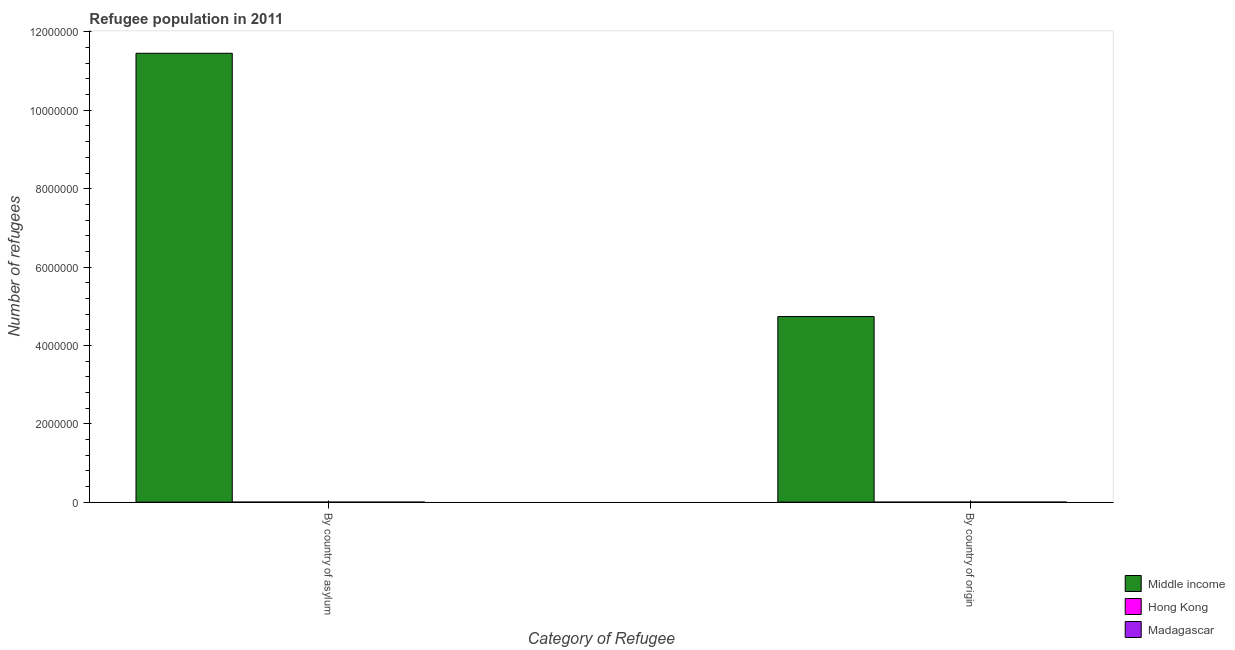Are the number of bars on each tick of the X-axis equal?
Your response must be concise. Yes. How many bars are there on the 2nd tick from the left?
Ensure brevity in your answer.  3. What is the label of the 2nd group of bars from the left?
Your response must be concise. By country of origin. What is the number of refugees by country of asylum in Madagascar?
Your answer should be very brief. 9. Across all countries, what is the maximum number of refugees by country of asylum?
Give a very brief answer. 1.15e+07. Across all countries, what is the minimum number of refugees by country of origin?
Give a very brief answer. 15. In which country was the number of refugees by country of origin minimum?
Keep it short and to the point. Hong Kong. What is the total number of refugees by country of asylum in the graph?
Provide a short and direct response. 1.15e+07. What is the difference between the number of refugees by country of asylum in Hong Kong and that in Madagascar?
Your answer should be compact. 143. What is the difference between the number of refugees by country of asylum in Madagascar and the number of refugees by country of origin in Hong Kong?
Provide a succinct answer. -6. What is the average number of refugees by country of asylum per country?
Ensure brevity in your answer.  3.82e+06. What is the difference between the number of refugees by country of origin and number of refugees by country of asylum in Hong Kong?
Provide a short and direct response. -137. In how many countries, is the number of refugees by country of asylum greater than 9600000 ?
Give a very brief answer. 1. What is the ratio of the number of refugees by country of origin in Middle income to that in Hong Kong?
Give a very brief answer. 3.16e+05. In how many countries, is the number of refugees by country of asylum greater than the average number of refugees by country of asylum taken over all countries?
Your answer should be compact. 1. What does the 2nd bar from the left in By country of origin represents?
Offer a terse response. Hong Kong. What does the 3rd bar from the right in By country of origin represents?
Ensure brevity in your answer.  Middle income. What is the difference between two consecutive major ticks on the Y-axis?
Offer a terse response. 2.00e+06. Are the values on the major ticks of Y-axis written in scientific E-notation?
Your response must be concise. No. How many legend labels are there?
Ensure brevity in your answer.  3. What is the title of the graph?
Your response must be concise. Refugee population in 2011. What is the label or title of the X-axis?
Give a very brief answer. Category of Refugee. What is the label or title of the Y-axis?
Your answer should be compact. Number of refugees. What is the Number of refugees in Middle income in By country of asylum?
Give a very brief answer. 1.15e+07. What is the Number of refugees in Hong Kong in By country of asylum?
Offer a very short reply. 152. What is the Number of refugees in Middle income in By country of origin?
Provide a short and direct response. 4.74e+06. What is the Number of refugees in Madagascar in By country of origin?
Offer a terse response. 289. Across all Category of Refugee, what is the maximum Number of refugees of Middle income?
Provide a short and direct response. 1.15e+07. Across all Category of Refugee, what is the maximum Number of refugees in Hong Kong?
Offer a very short reply. 152. Across all Category of Refugee, what is the maximum Number of refugees in Madagascar?
Ensure brevity in your answer.  289. Across all Category of Refugee, what is the minimum Number of refugees in Middle income?
Offer a terse response. 4.74e+06. What is the total Number of refugees in Middle income in the graph?
Offer a very short reply. 1.62e+07. What is the total Number of refugees in Hong Kong in the graph?
Provide a short and direct response. 167. What is the total Number of refugees of Madagascar in the graph?
Offer a terse response. 298. What is the difference between the Number of refugees of Middle income in By country of asylum and that in By country of origin?
Offer a terse response. 6.72e+06. What is the difference between the Number of refugees of Hong Kong in By country of asylum and that in By country of origin?
Provide a short and direct response. 137. What is the difference between the Number of refugees of Madagascar in By country of asylum and that in By country of origin?
Offer a terse response. -280. What is the difference between the Number of refugees in Middle income in By country of asylum and the Number of refugees in Hong Kong in By country of origin?
Your answer should be very brief. 1.15e+07. What is the difference between the Number of refugees of Middle income in By country of asylum and the Number of refugees of Madagascar in By country of origin?
Your response must be concise. 1.15e+07. What is the difference between the Number of refugees of Hong Kong in By country of asylum and the Number of refugees of Madagascar in By country of origin?
Your response must be concise. -137. What is the average Number of refugees in Middle income per Category of Refugee?
Offer a very short reply. 8.10e+06. What is the average Number of refugees in Hong Kong per Category of Refugee?
Provide a short and direct response. 83.5. What is the average Number of refugees of Madagascar per Category of Refugee?
Provide a succinct answer. 149. What is the difference between the Number of refugees in Middle income and Number of refugees in Hong Kong in By country of asylum?
Your response must be concise. 1.15e+07. What is the difference between the Number of refugees in Middle income and Number of refugees in Madagascar in By country of asylum?
Keep it short and to the point. 1.15e+07. What is the difference between the Number of refugees in Hong Kong and Number of refugees in Madagascar in By country of asylum?
Your answer should be compact. 143. What is the difference between the Number of refugees in Middle income and Number of refugees in Hong Kong in By country of origin?
Give a very brief answer. 4.74e+06. What is the difference between the Number of refugees in Middle income and Number of refugees in Madagascar in By country of origin?
Provide a succinct answer. 4.74e+06. What is the difference between the Number of refugees in Hong Kong and Number of refugees in Madagascar in By country of origin?
Offer a terse response. -274. What is the ratio of the Number of refugees in Middle income in By country of asylum to that in By country of origin?
Your answer should be compact. 2.42. What is the ratio of the Number of refugees in Hong Kong in By country of asylum to that in By country of origin?
Give a very brief answer. 10.13. What is the ratio of the Number of refugees of Madagascar in By country of asylum to that in By country of origin?
Offer a terse response. 0.03. What is the difference between the highest and the second highest Number of refugees in Middle income?
Your answer should be very brief. 6.72e+06. What is the difference between the highest and the second highest Number of refugees in Hong Kong?
Provide a short and direct response. 137. What is the difference between the highest and the second highest Number of refugees in Madagascar?
Your answer should be compact. 280. What is the difference between the highest and the lowest Number of refugees in Middle income?
Give a very brief answer. 6.72e+06. What is the difference between the highest and the lowest Number of refugees in Hong Kong?
Make the answer very short. 137. What is the difference between the highest and the lowest Number of refugees of Madagascar?
Provide a short and direct response. 280. 